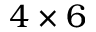Convert formula to latex. <formula><loc_0><loc_0><loc_500><loc_500>4 \times 6</formula> 